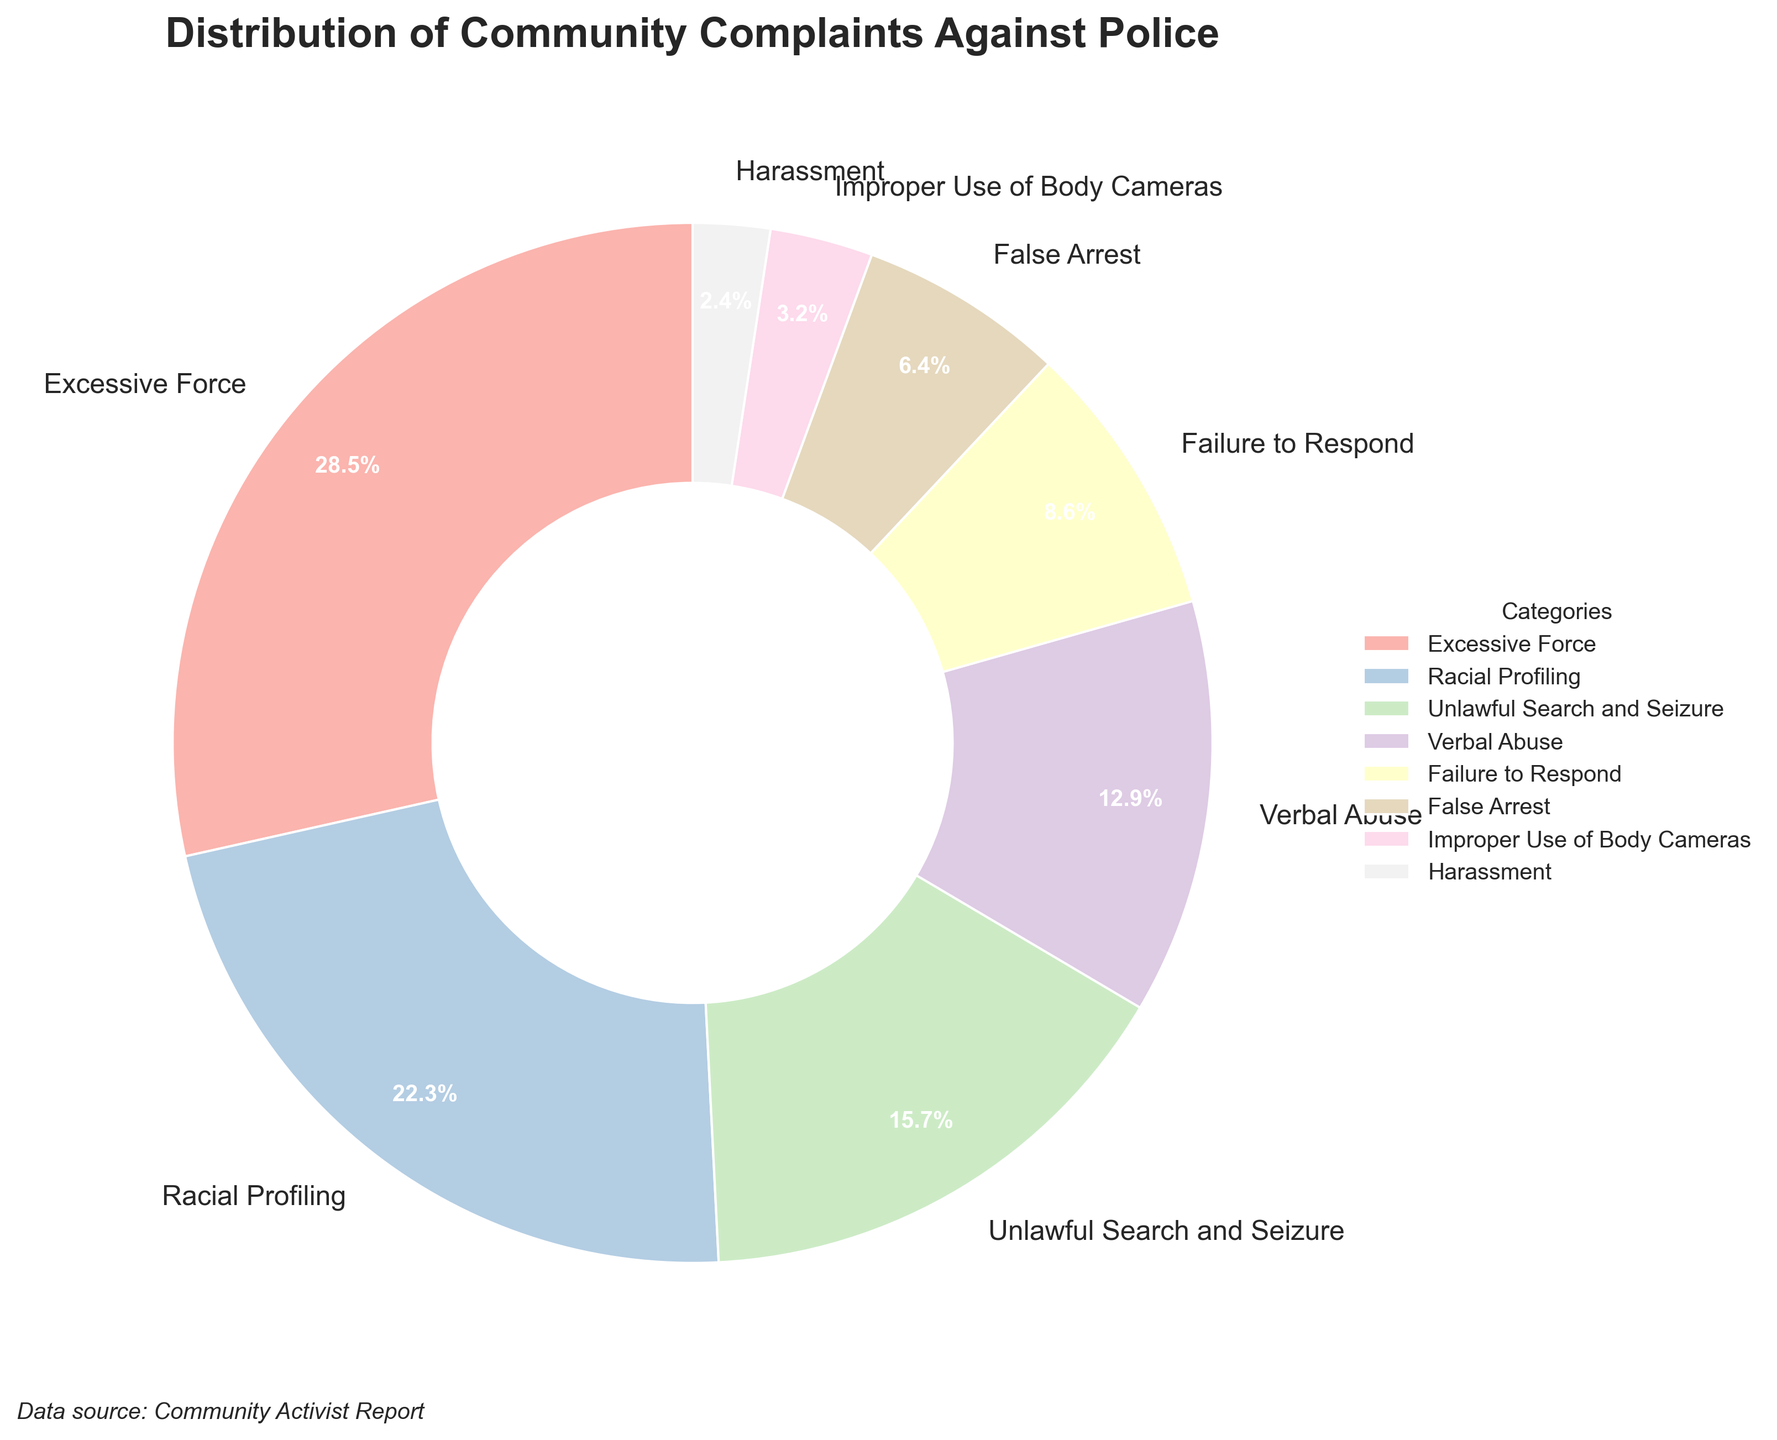Which category has the highest percentage of complaints? To identify the category with the highest percentage, locate the largest slice in the pie chart. The slice labeled "Excessive Force" is the largest.
Answer: Excessive Force Which two categories have the smallest percentages of complaints combined? Identify the two smallest slices in the pie chart, which are labeled "Harassment" and "Improper Use of Body Cameras". Sum their percentages: 2.4% + 3.2% = 5.6%.
Answer: Harassment and Improper Use of Body Cameras What is the difference in the percentage of complaints between Racial Profiling and False Arrest? Locate the slices for "Racial Profiling" (22.3%) and "False Arrest" (6.4%), then subtract the smaller percentage from the larger one: 22.3% - 6.4% = 15.9%.
Answer: 15.9% How many categories have a percentage of complaints greater than 10%? Count the number of slices with percentages above 10%: "Excessive Force" (28.5%), "Racial Profiling" (22.3%), "Unlawful Search and Seizure" (15.7%), and "Verbal Abuse" (12.9%). There are four such categories.
Answer: Four Which category’s percentage is closest to 10%? Compare the percentages of each category to 10% and locate the one closest to this value. "Failure to Respond" has a percentage of 8.6%, which is the closest to 10%.
Answer: Failure to Respond What is the combined percentage of the categories representing non-physical complaints (Verbal Abuse, Failure to Respond, Harassment)? Locate the slices for "Verbal Abuse" (12.9%), "Failure to Respond" (8.6%), and "Harassment" (2.4%), then sum their percentages: 12.9% + 8.6% + 2.4% = 23.9%.
Answer: 23.9% Which category has a percentage almost one-fifth of the total complaints? Calculate one-fifth of 100%, which is 20%, then find the category closest to this value. "Racial Profiling" has a percentage of 22.3%, which is nearly one-fifth.
Answer: Racial Profiling 